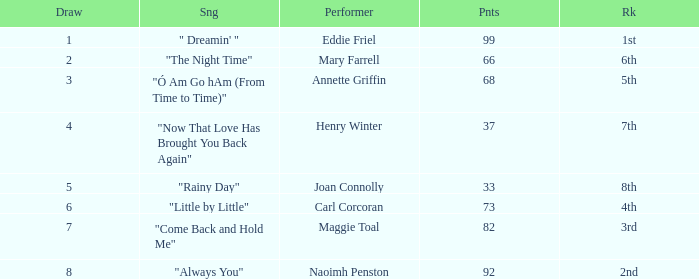What is the average number of points when the ranking is 7th and the draw is less than 4? None. 